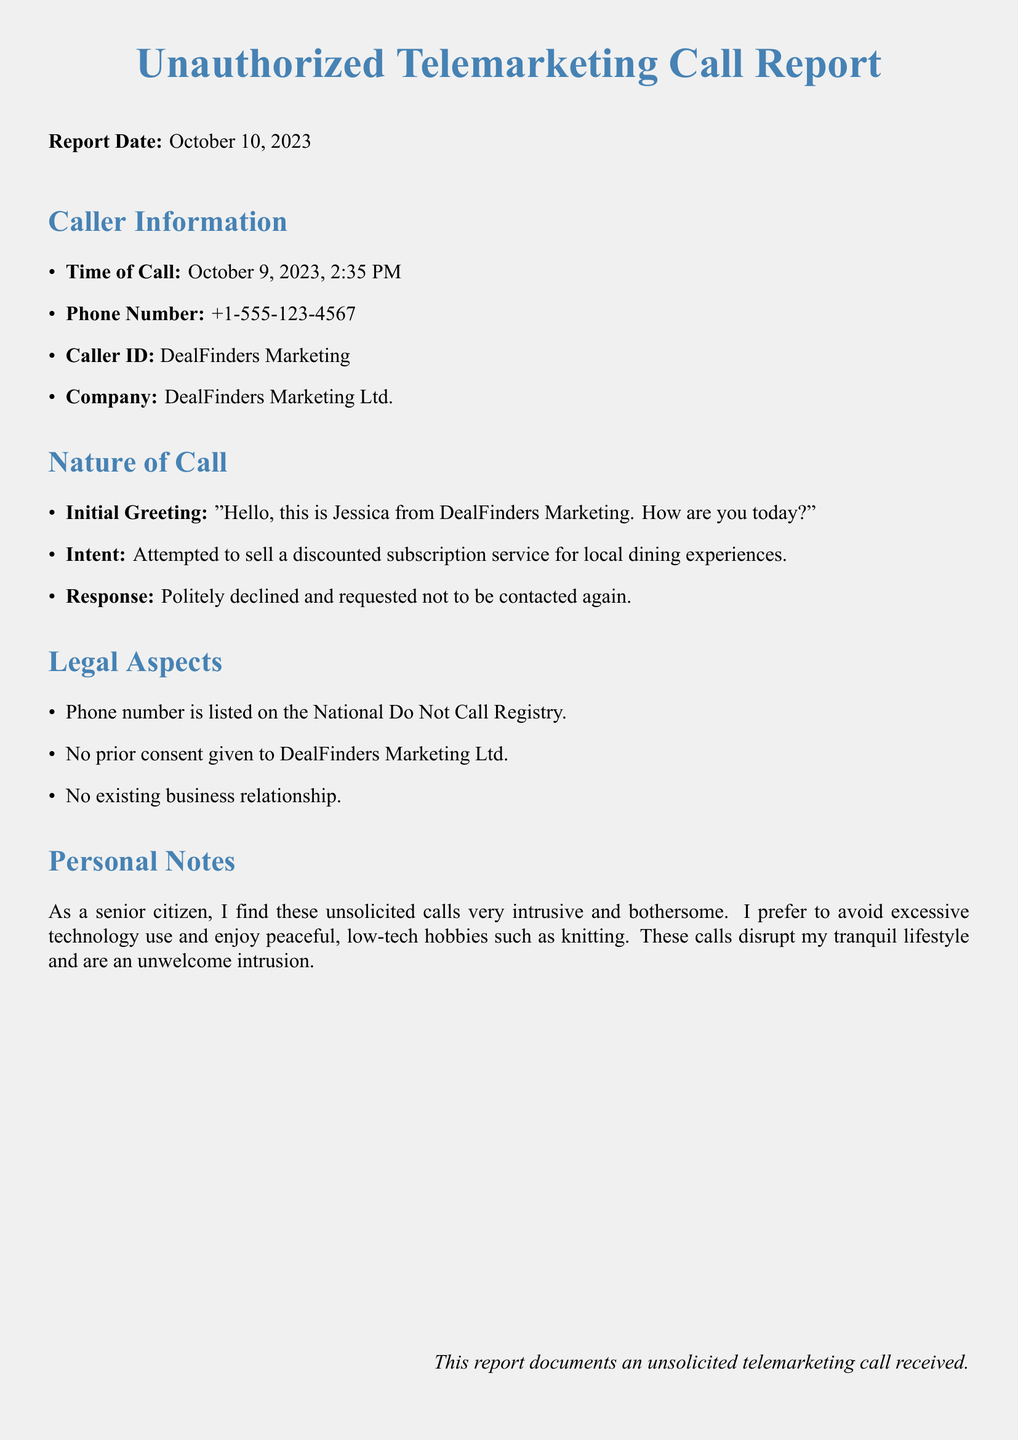What is the report date? The report date is mentioned at the beginning of the document.
Answer: October 10, 2023 What time was the call received? The time of the call is listed under Caller Information in the document.
Answer: 2:35 PM Who is the caller? The caller is identified in the Caller Information section of the report.
Answer: DealFinders Marketing What was the intent of the call? The intent of the call is described under the Nature of Call section.
Answer: Attempted to sell a discounted subscription service for local dining experiences Is the phone number registered on the National Do Not Call Registry? The legal aspects section confirms the status of the phone number.
Answer: Yes How did the recipient respond to the call? The recipient's response is detailed in the Nature of Call section.
Answer: Politely declined and requested not to be contacted again What is the company's name? The company's name is found in the Caller Information section.
Answer: DealFinders Marketing Ltd What kind of disturbances do unsolicited calls cause to the author? The author expressed their feelings in the Personal Notes section.
Answer: Intrusive and bothersome Was there a prior consent given to the caller? The legal aspects section addresses the matter of consent regarding the call.
Answer: No 